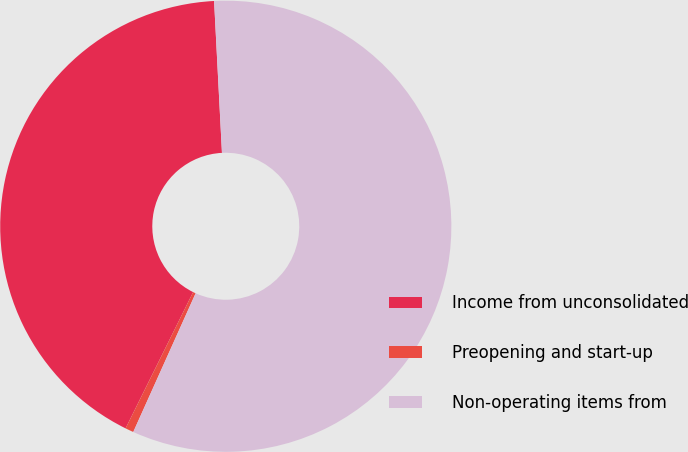<chart> <loc_0><loc_0><loc_500><loc_500><pie_chart><fcel>Income from unconsolidated<fcel>Preopening and start-up<fcel>Non-operating items from<nl><fcel>41.85%<fcel>0.6%<fcel>57.55%<nl></chart> 